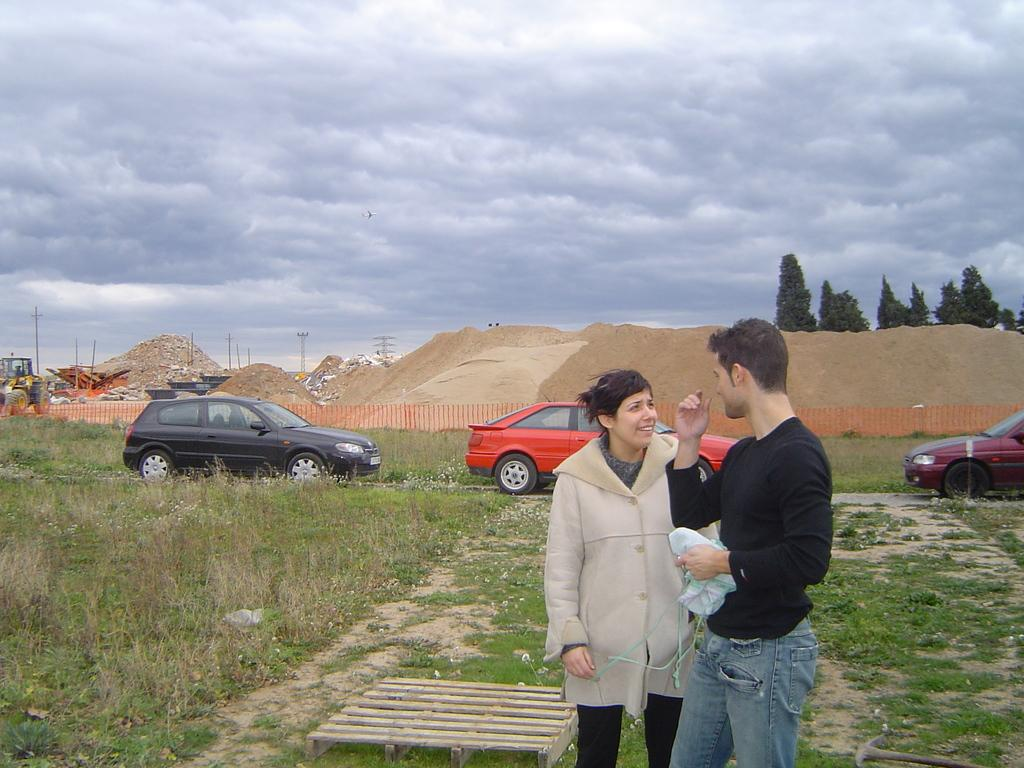How many people are present in the image? There are two people, a man and a woman, present in the image. What is the ground surface like in the image? The ground is covered with grass. What type of vehicles can be seen in the image? Cars and a vehicle are visible in the image. What is visible in the background of the image? Poles, trees, sand, a fence, a vehicle, and the sky are visible in the background of the image. What is the condition of the sky in the image? The sky is visible in the background of the image, and clouds are present. What type of stove can be seen in the image? There is no stove present in the image. How many members are on the team in the image? There is no team present in the image. 